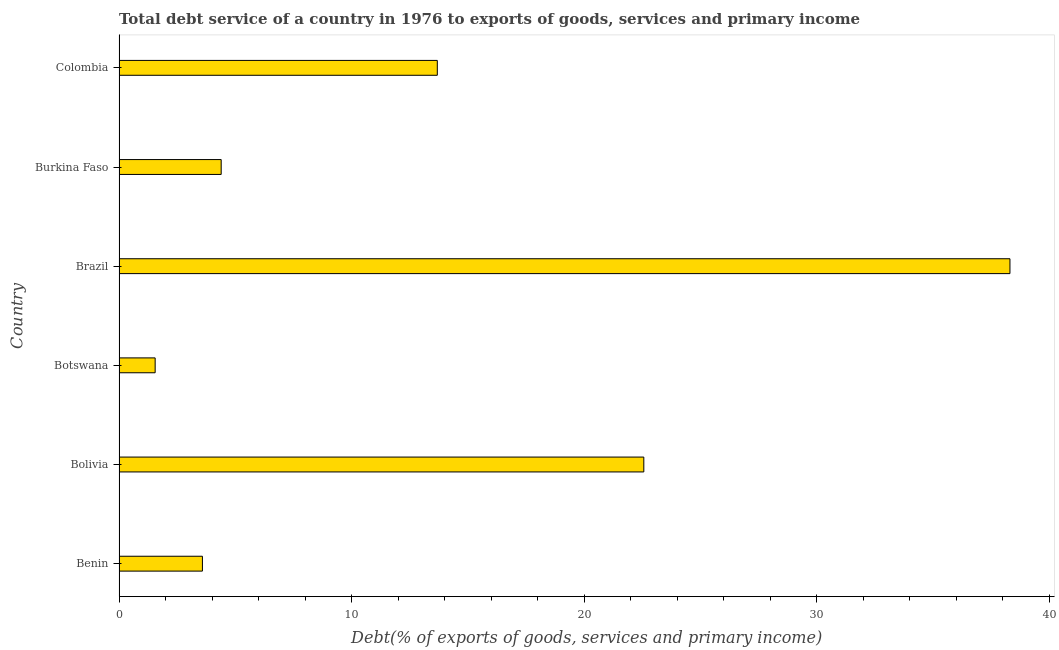Does the graph contain any zero values?
Offer a terse response. No. Does the graph contain grids?
Give a very brief answer. No. What is the title of the graph?
Your answer should be very brief. Total debt service of a country in 1976 to exports of goods, services and primary income. What is the label or title of the X-axis?
Ensure brevity in your answer.  Debt(% of exports of goods, services and primary income). What is the label or title of the Y-axis?
Offer a terse response. Country. What is the total debt service in Brazil?
Give a very brief answer. 38.32. Across all countries, what is the maximum total debt service?
Offer a terse response. 38.32. Across all countries, what is the minimum total debt service?
Provide a short and direct response. 1.55. In which country was the total debt service minimum?
Make the answer very short. Botswana. What is the sum of the total debt service?
Your response must be concise. 84.1. What is the difference between the total debt service in Bolivia and Colombia?
Provide a succinct answer. 8.88. What is the average total debt service per country?
Give a very brief answer. 14.02. What is the median total debt service?
Make the answer very short. 9.04. In how many countries, is the total debt service greater than 24 %?
Provide a succinct answer. 1. What is the ratio of the total debt service in Bolivia to that in Colombia?
Your response must be concise. 1.65. What is the difference between the highest and the second highest total debt service?
Your response must be concise. 15.75. What is the difference between the highest and the lowest total debt service?
Provide a short and direct response. 36.76. How many bars are there?
Your response must be concise. 6. How many countries are there in the graph?
Offer a very short reply. 6. What is the difference between two consecutive major ticks on the X-axis?
Your answer should be compact. 10. What is the Debt(% of exports of goods, services and primary income) of Benin?
Your response must be concise. 3.59. What is the Debt(% of exports of goods, services and primary income) of Bolivia?
Give a very brief answer. 22.57. What is the Debt(% of exports of goods, services and primary income) of Botswana?
Provide a short and direct response. 1.55. What is the Debt(% of exports of goods, services and primary income) in Brazil?
Make the answer very short. 38.32. What is the Debt(% of exports of goods, services and primary income) in Burkina Faso?
Give a very brief answer. 4.39. What is the Debt(% of exports of goods, services and primary income) of Colombia?
Offer a terse response. 13.69. What is the difference between the Debt(% of exports of goods, services and primary income) in Benin and Bolivia?
Provide a succinct answer. -18.98. What is the difference between the Debt(% of exports of goods, services and primary income) in Benin and Botswana?
Offer a terse response. 2.03. What is the difference between the Debt(% of exports of goods, services and primary income) in Benin and Brazil?
Make the answer very short. -34.73. What is the difference between the Debt(% of exports of goods, services and primary income) in Benin and Burkina Faso?
Your answer should be very brief. -0.81. What is the difference between the Debt(% of exports of goods, services and primary income) in Benin and Colombia?
Provide a succinct answer. -10.1. What is the difference between the Debt(% of exports of goods, services and primary income) in Bolivia and Botswana?
Ensure brevity in your answer.  21.02. What is the difference between the Debt(% of exports of goods, services and primary income) in Bolivia and Brazil?
Make the answer very short. -15.75. What is the difference between the Debt(% of exports of goods, services and primary income) in Bolivia and Burkina Faso?
Provide a short and direct response. 18.18. What is the difference between the Debt(% of exports of goods, services and primary income) in Bolivia and Colombia?
Offer a terse response. 8.88. What is the difference between the Debt(% of exports of goods, services and primary income) in Botswana and Brazil?
Your answer should be very brief. -36.76. What is the difference between the Debt(% of exports of goods, services and primary income) in Botswana and Burkina Faso?
Provide a short and direct response. -2.84. What is the difference between the Debt(% of exports of goods, services and primary income) in Botswana and Colombia?
Ensure brevity in your answer.  -12.14. What is the difference between the Debt(% of exports of goods, services and primary income) in Brazil and Burkina Faso?
Ensure brevity in your answer.  33.92. What is the difference between the Debt(% of exports of goods, services and primary income) in Brazil and Colombia?
Offer a very short reply. 24.63. What is the difference between the Debt(% of exports of goods, services and primary income) in Burkina Faso and Colombia?
Your answer should be compact. -9.29. What is the ratio of the Debt(% of exports of goods, services and primary income) in Benin to that in Bolivia?
Offer a very short reply. 0.16. What is the ratio of the Debt(% of exports of goods, services and primary income) in Benin to that in Botswana?
Keep it short and to the point. 2.31. What is the ratio of the Debt(% of exports of goods, services and primary income) in Benin to that in Brazil?
Your response must be concise. 0.09. What is the ratio of the Debt(% of exports of goods, services and primary income) in Benin to that in Burkina Faso?
Provide a short and direct response. 0.82. What is the ratio of the Debt(% of exports of goods, services and primary income) in Benin to that in Colombia?
Make the answer very short. 0.26. What is the ratio of the Debt(% of exports of goods, services and primary income) in Bolivia to that in Botswana?
Ensure brevity in your answer.  14.54. What is the ratio of the Debt(% of exports of goods, services and primary income) in Bolivia to that in Brazil?
Ensure brevity in your answer.  0.59. What is the ratio of the Debt(% of exports of goods, services and primary income) in Bolivia to that in Burkina Faso?
Offer a very short reply. 5.14. What is the ratio of the Debt(% of exports of goods, services and primary income) in Bolivia to that in Colombia?
Make the answer very short. 1.65. What is the ratio of the Debt(% of exports of goods, services and primary income) in Botswana to that in Brazil?
Offer a very short reply. 0.04. What is the ratio of the Debt(% of exports of goods, services and primary income) in Botswana to that in Burkina Faso?
Give a very brief answer. 0.35. What is the ratio of the Debt(% of exports of goods, services and primary income) in Botswana to that in Colombia?
Offer a very short reply. 0.11. What is the ratio of the Debt(% of exports of goods, services and primary income) in Brazil to that in Burkina Faso?
Keep it short and to the point. 8.72. What is the ratio of the Debt(% of exports of goods, services and primary income) in Brazil to that in Colombia?
Provide a succinct answer. 2.8. What is the ratio of the Debt(% of exports of goods, services and primary income) in Burkina Faso to that in Colombia?
Provide a succinct answer. 0.32. 